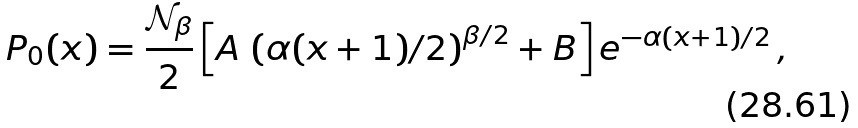<formula> <loc_0><loc_0><loc_500><loc_500>P _ { 0 } ( x ) = \frac { { \mathcal { N } } _ { \beta } } { 2 } \left [ A \, \left ( \alpha ( x + 1 ) / 2 \right ) ^ { \beta / 2 } + B \right ] e ^ { - \alpha ( x + 1 ) / 2 } \, ,</formula> 